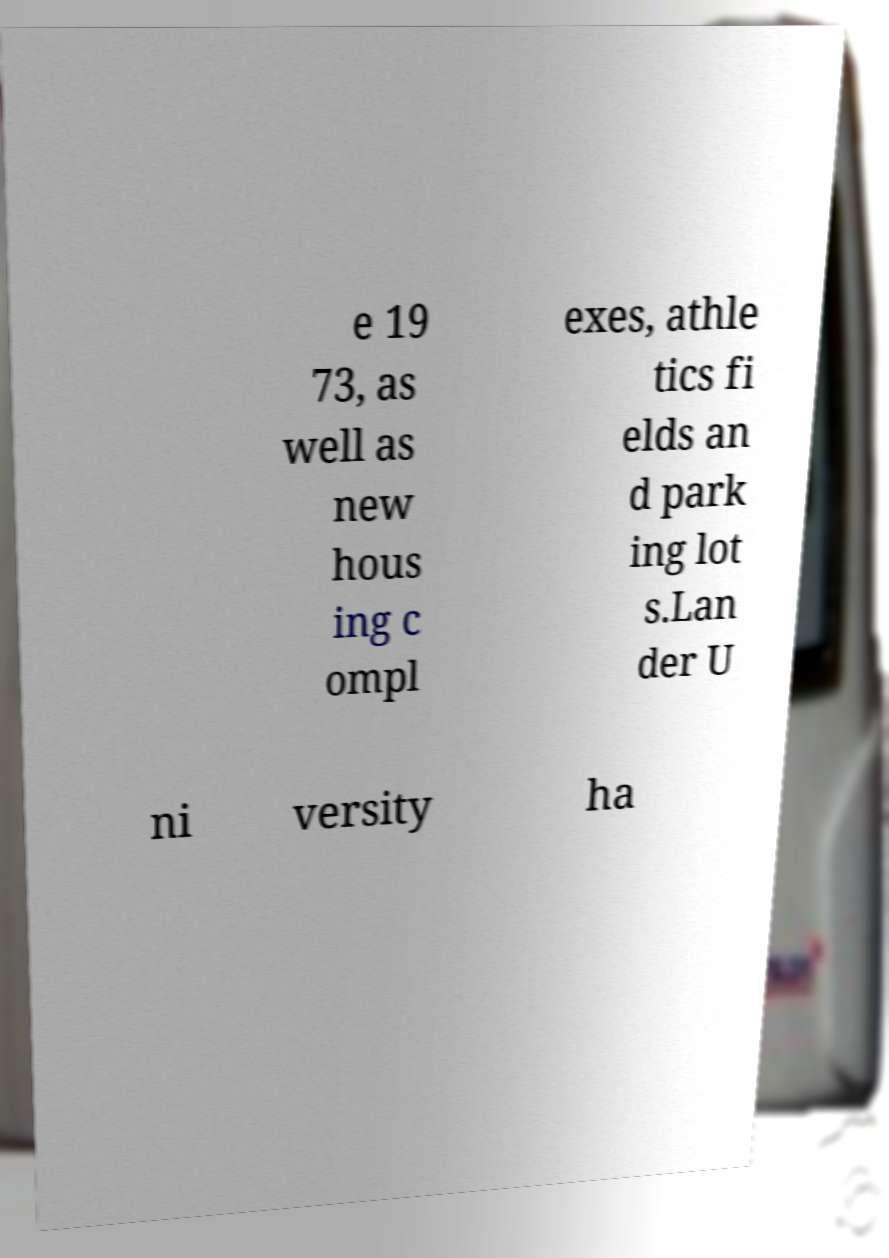Can you read and provide the text displayed in the image?This photo seems to have some interesting text. Can you extract and type it out for me? e 19 73, as well as new hous ing c ompl exes, athle tics fi elds an d park ing lot s.Lan der U ni versity ha 